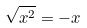Convert formula to latex. <formula><loc_0><loc_0><loc_500><loc_500>\sqrt { x ^ { 2 } } = - x</formula> 